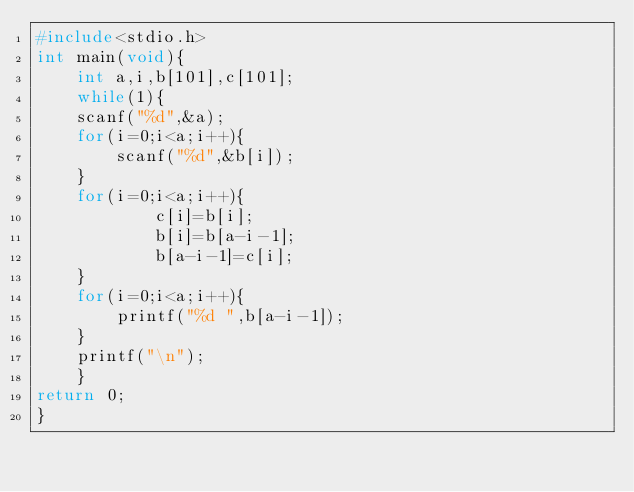<code> <loc_0><loc_0><loc_500><loc_500><_C_>#include<stdio.h>
int main(void){
    int a,i,b[101],c[101];
    while(1){
    scanf("%d",&a);
    for(i=0;i<a;i++){
        scanf("%d",&b[i]);
    }
    for(i=0;i<a;i++){
            c[i]=b[i];
            b[i]=b[a-i-1];
            b[a-i-1]=c[i];
    }
    for(i=0;i<a;i++){
        printf("%d ",b[a-i-1]);
    }
    printf("\n");
    }
return 0;
}</code> 